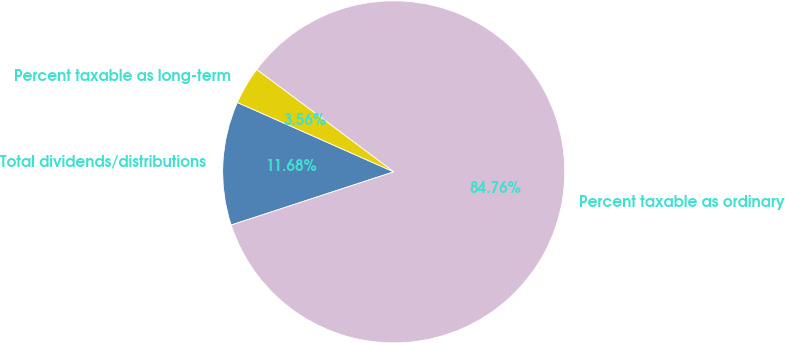Convert chart to OTSL. <chart><loc_0><loc_0><loc_500><loc_500><pie_chart><fcel>Total dividends/distributions<fcel>Percent taxable as ordinary<fcel>Percent taxable as long-term<nl><fcel>11.68%<fcel>84.76%<fcel>3.56%<nl></chart> 